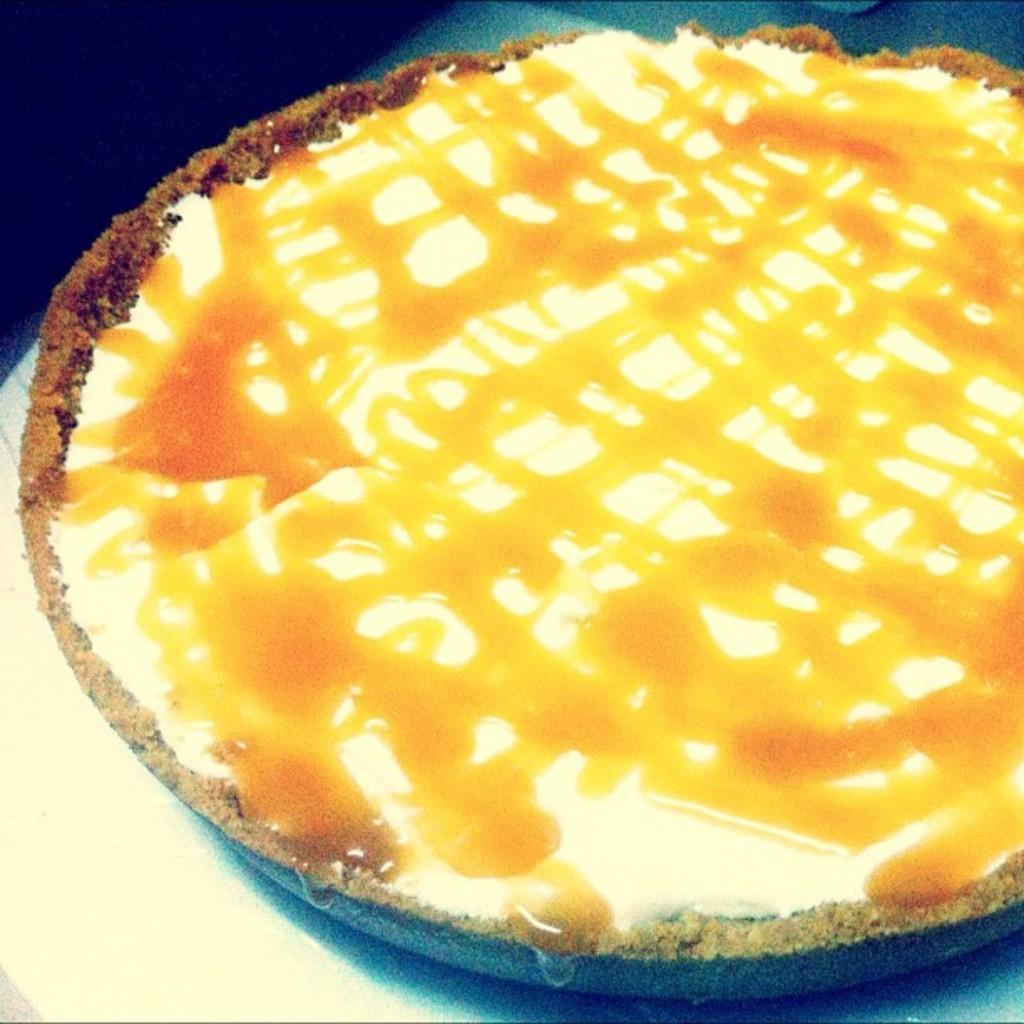What is the main subject of the image? There is a food item in the image. Where is the food item located? The food item is on a platform. How many cherries are on the lamp in the image? There are no cherries or lamps present in the image. 